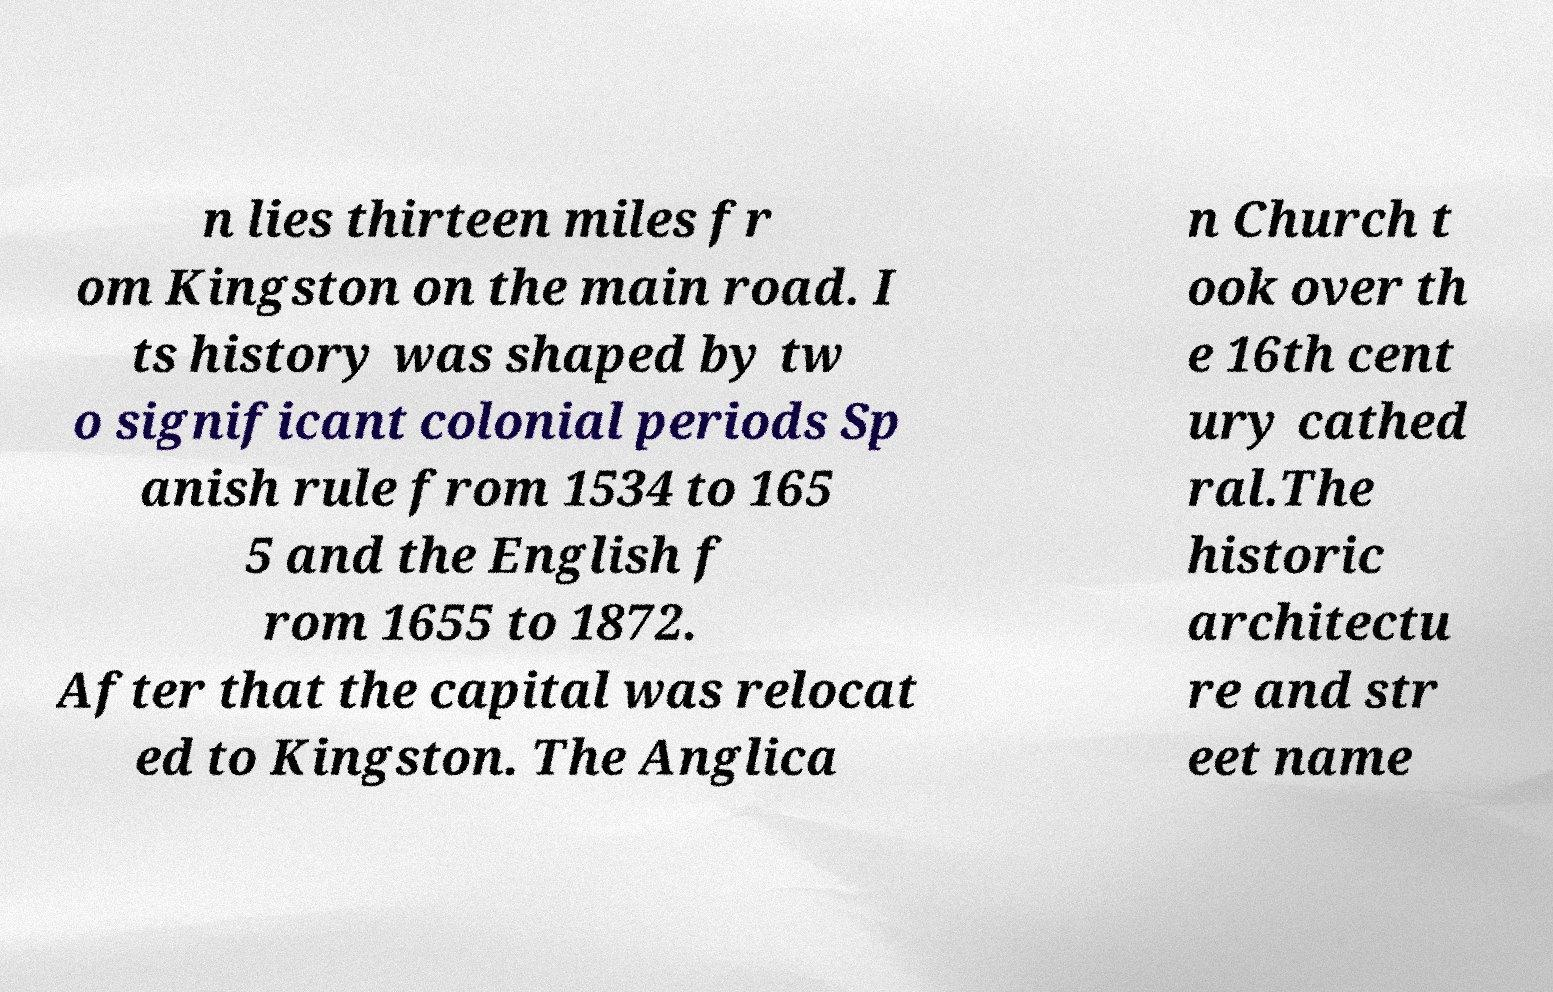Could you extract and type out the text from this image? n lies thirteen miles fr om Kingston on the main road. I ts history was shaped by tw o significant colonial periods Sp anish rule from 1534 to 165 5 and the English f rom 1655 to 1872. After that the capital was relocat ed to Kingston. The Anglica n Church t ook over th e 16th cent ury cathed ral.The historic architectu re and str eet name 